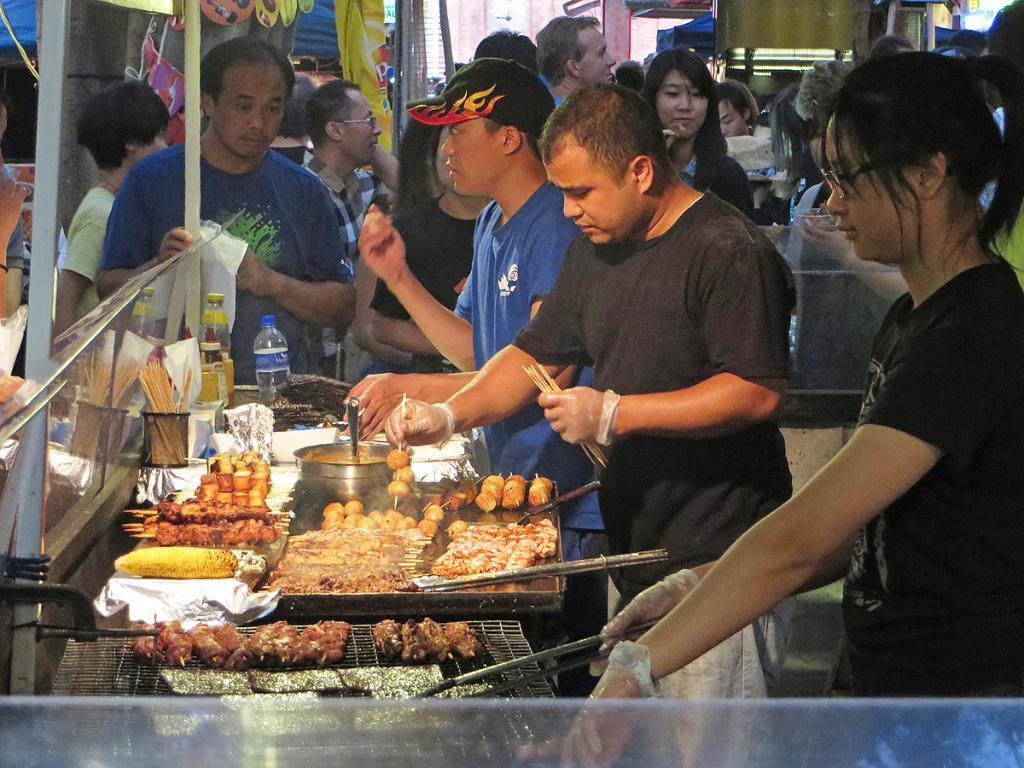What is present on the table in the image? There is food visible on the table. What is the person holding in the image? The person is holding sticks. How many other persons can be seen in the image? There are other persons visible in the image. What is the distance between the person and the building in the image? There is no building present in the image, so it is not possible to determine the distance between the person and a building. 